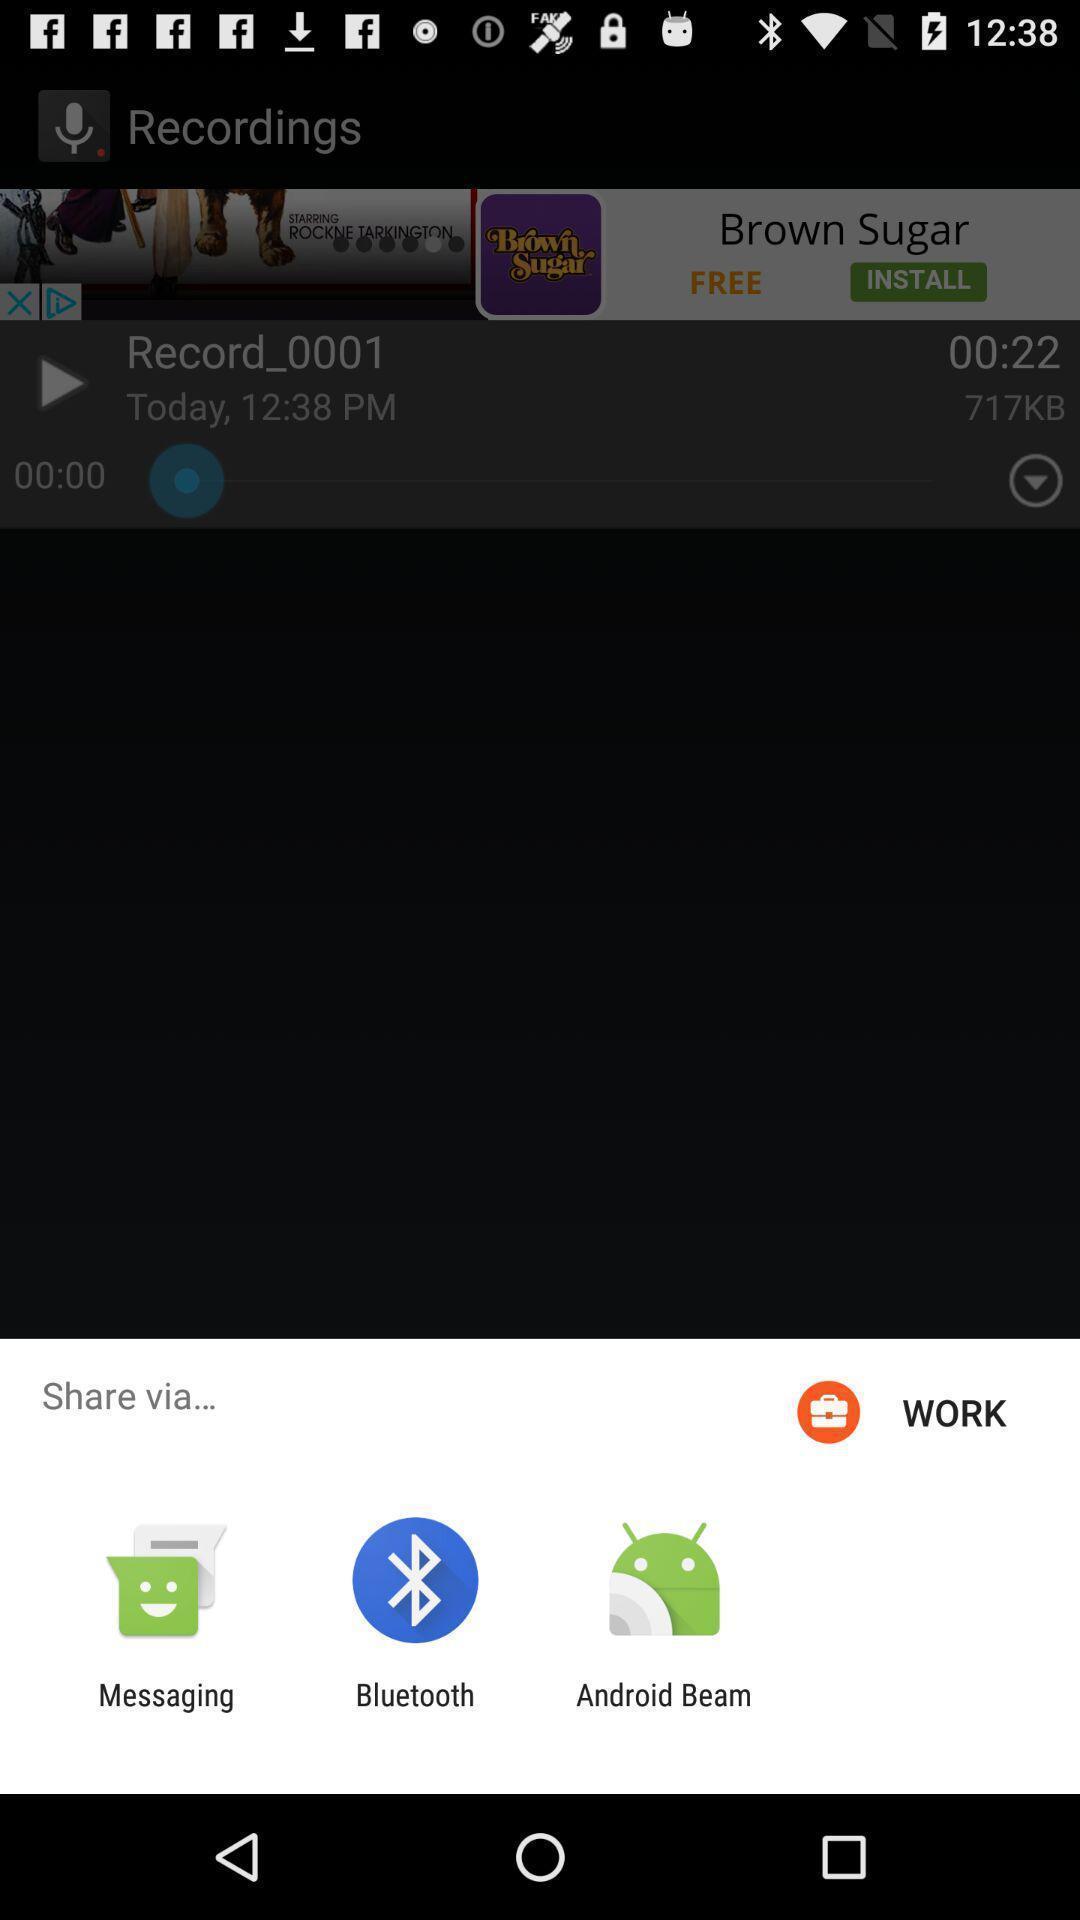Describe the key features of this screenshot. Pop-up showing different sharing options. 